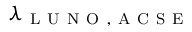<formula> <loc_0><loc_0><loc_500><loc_500>\lambda _ { L U N O , A C S E }</formula> 